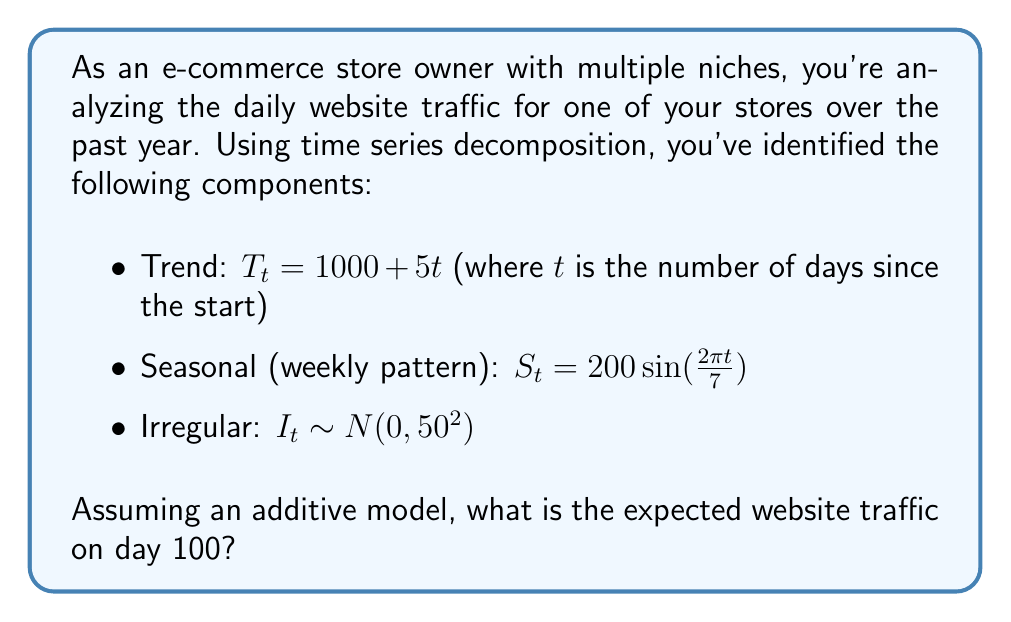Show me your answer to this math problem. To solve this problem, we'll use the additive time series decomposition model:

$Y_t = T_t + S_t + I_t$

Where:
$Y_t$ is the observed value (website traffic)
$T_t$ is the trend component
$S_t$ is the seasonal component
$I_t$ is the irregular component

Let's calculate each component for day 100:

1. Trend component:
   $T_{100} = 1000 + 5(100) = 1500$

2. Seasonal component:
   $S_{100} = 200 \sin(\frac{2\pi \cdot 100}{7}) \approx -38.27$

3. Irregular component:
   The expected value of the irregular component is 0, as it follows a normal distribution with mean 0.

Now, we can sum these components:

$Y_{100} = T_{100} + S_{100} + E[I_{100}]$
$Y_{100} = 1500 + (-38.27) + 0 = 1461.73$

Therefore, the expected website traffic on day 100 is approximately 1462 visitors.
Answer: 1462 visitors 